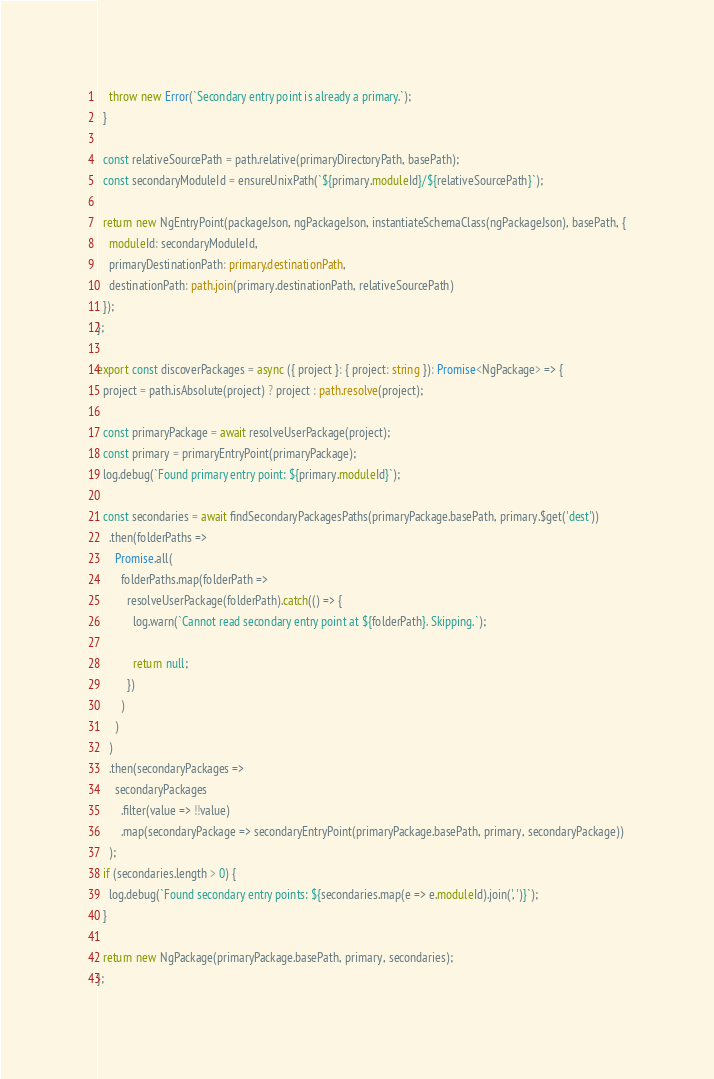<code> <loc_0><loc_0><loc_500><loc_500><_TypeScript_>    throw new Error(`Secondary entry point is already a primary.`);
  }

  const relativeSourcePath = path.relative(primaryDirectoryPath, basePath);
  const secondaryModuleId = ensureUnixPath(`${primary.moduleId}/${relativeSourcePath}`);

  return new NgEntryPoint(packageJson, ngPackageJson, instantiateSchemaClass(ngPackageJson), basePath, {
    moduleId: secondaryModuleId,
    primaryDestinationPath: primary.destinationPath,
    destinationPath: path.join(primary.destinationPath, relativeSourcePath)
  });
};

export const discoverPackages = async ({ project }: { project: string }): Promise<NgPackage> => {
  project = path.isAbsolute(project) ? project : path.resolve(project);

  const primaryPackage = await resolveUserPackage(project);
  const primary = primaryEntryPoint(primaryPackage);
  log.debug(`Found primary entry point: ${primary.moduleId}`);

  const secondaries = await findSecondaryPackagesPaths(primaryPackage.basePath, primary.$get('dest'))
    .then(folderPaths =>
      Promise.all(
        folderPaths.map(folderPath =>
          resolveUserPackage(folderPath).catch(() => {
            log.warn(`Cannot read secondary entry point at ${folderPath}. Skipping.`);

            return null;
          })
        )
      )
    )
    .then(secondaryPackages =>
      secondaryPackages
        .filter(value => !!value)
        .map(secondaryPackage => secondaryEntryPoint(primaryPackage.basePath, primary, secondaryPackage))
    );
  if (secondaries.length > 0) {
    log.debug(`Found secondary entry points: ${secondaries.map(e => e.moduleId).join(', ')}`);
  }

  return new NgPackage(primaryPackage.basePath, primary, secondaries);
};
</code> 